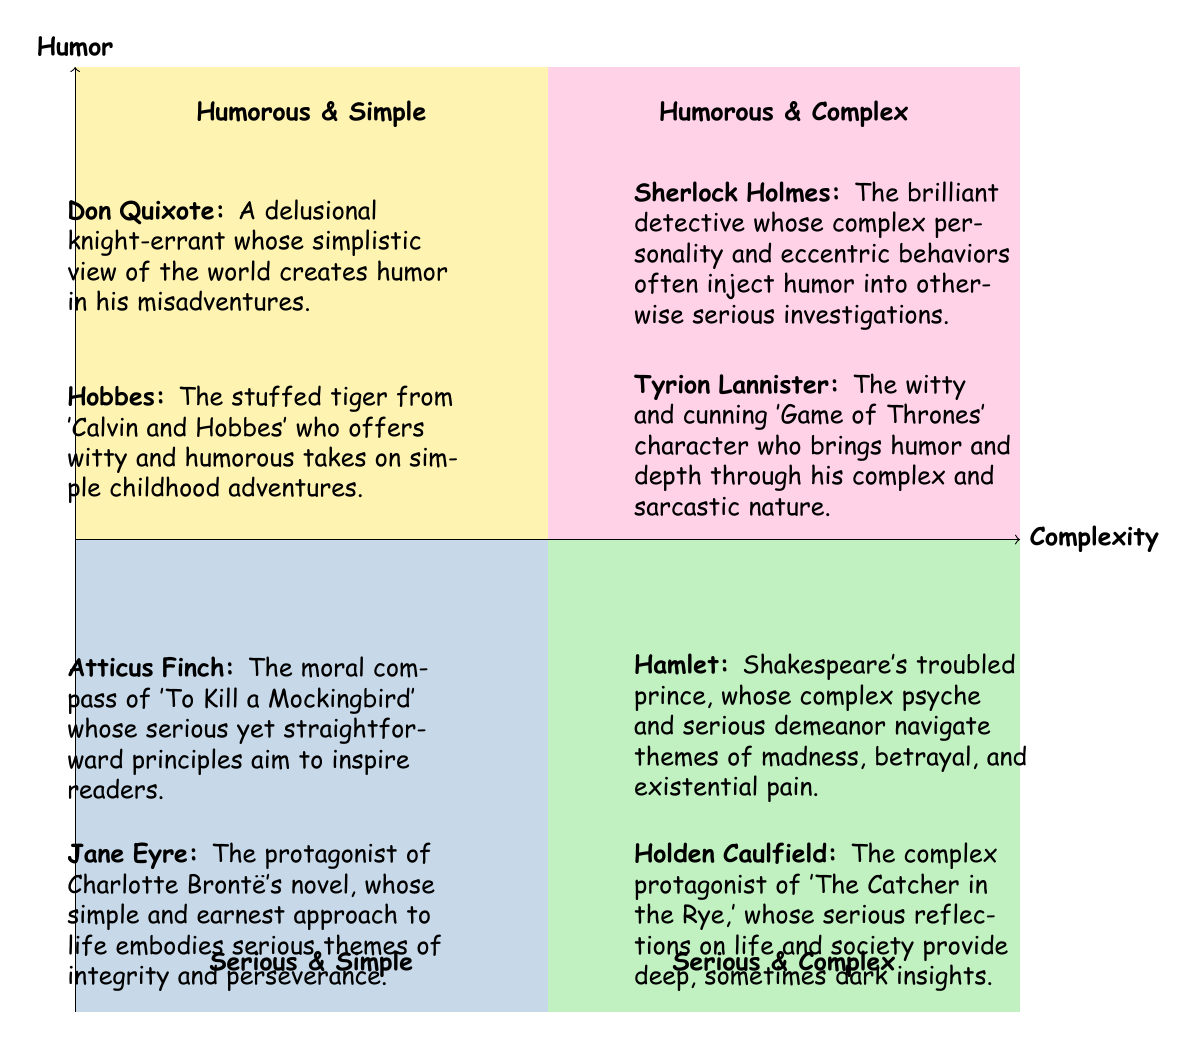What is the title of the top-left quadrant? The title of the top-left quadrant is displayed prominently within that section of the diagram. It reads "Humorous & Simple."
Answer: Humorous & Simple Which character is in the bottom-right quadrant? The bottom-right quadrant contains the character "Holden Caulfield." This is indicated by the character description placed within that section.
Answer: Holden Caulfield How many characters are listed in the "Serious & Simple" quadrant? By examining the "Serious & Simple" quadrant, you can count two characters: "Atticus Finch" and "Jane Eyre." Thus, the total is two characters.
Answer: 2 What connects "Tyrion Lannister" and "Hamlet" in the diagram? Both "Tyrion Lannister" and "Hamlet" are located in quadrants where characters exhibit complexity and seriousness. They are positioned diagonally across from each other, representing different combinations of humor and complexity.
Answer: Complexity Which character has a humorous role in the "Humorous & Complex" quadrant? The character "Sherlock Holmes" is found in the "Humorous & Complex" quadrant. The description indicates that he infuses humor into his serious role.
Answer: Sherlock Holmes In total, how many characters are both serious and complex? In the "Serious & Complex" quadrant, two characters are shown: "Hamlet" and "Holden Caulfield." Therefore, the total count is two characters who embody these traits.
Answer: 2 What is the main theme described by "Atticus Finch"? The character "Atticus Finch" is described in the "Serious & Simple" quadrant, focusing on themes of morality and inspiration. The text emphasizes his serious yet straightforward principles.
Answer: Morality Which quadrant contains characters that embody themes of simplicity and humor? The "Humorous & Simple" quadrant specifically features characters that are both humorous and straightforward. The examples provided illustrate this combination clearly.
Answer: Humorous & Simple 